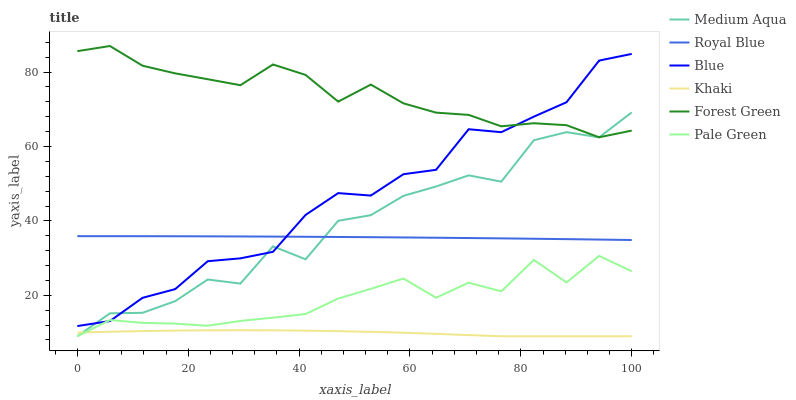Does Royal Blue have the minimum area under the curve?
Answer yes or no. No. Does Royal Blue have the maximum area under the curve?
Answer yes or no. No. Is Khaki the smoothest?
Answer yes or no. No. Is Khaki the roughest?
Answer yes or no. No. Does Royal Blue have the lowest value?
Answer yes or no. No. Does Royal Blue have the highest value?
Answer yes or no. No. Is Pale Green less than Royal Blue?
Answer yes or no. Yes. Is Royal Blue greater than Pale Green?
Answer yes or no. Yes. Does Pale Green intersect Royal Blue?
Answer yes or no. No. 